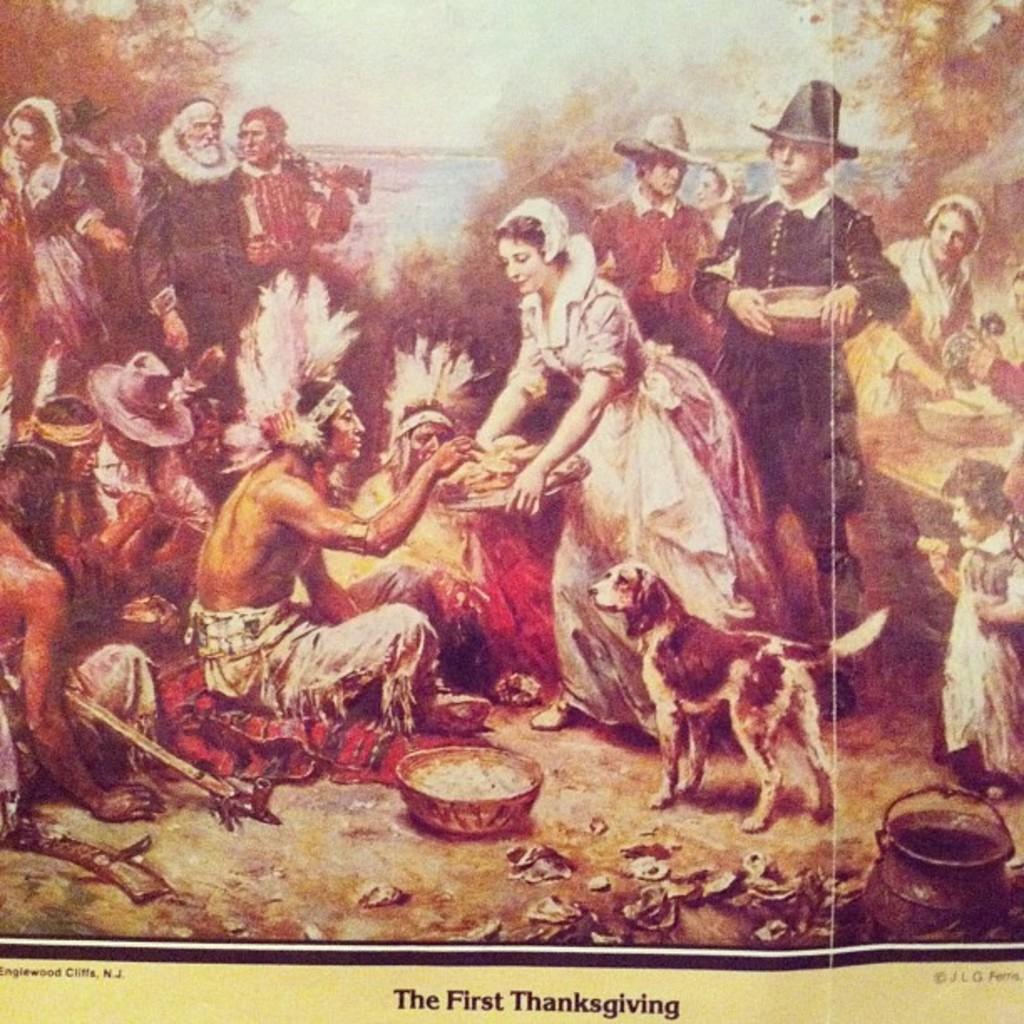Can you describe this image briefly? In this image, we can see a poster. In this poster, we can see a group of people. Few people are standing. Here a woman is holding an object. At the bottom, we can see a dog is standing on the ground. At the bottom of the image, we can see some text. 